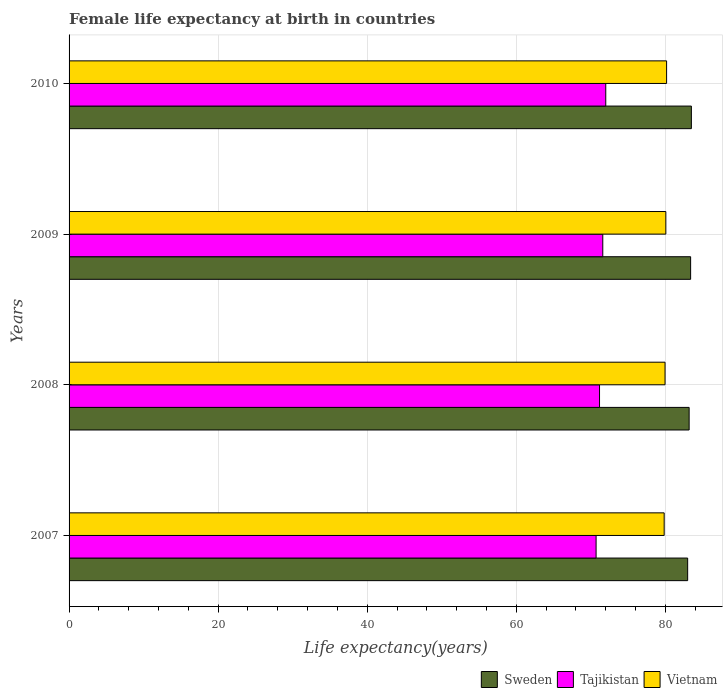How many different coloured bars are there?
Provide a succinct answer. 3. Are the number of bars per tick equal to the number of legend labels?
Ensure brevity in your answer.  Yes. How many bars are there on the 3rd tick from the top?
Offer a terse response. 3. In how many cases, is the number of bars for a given year not equal to the number of legend labels?
Keep it short and to the point. 0. What is the female life expectancy at birth in Vietnam in 2007?
Provide a short and direct response. 79.85. Across all years, what is the maximum female life expectancy at birth in Sweden?
Provide a short and direct response. 83.5. Across all years, what is the minimum female life expectancy at birth in Tajikistan?
Keep it short and to the point. 70.72. In which year was the female life expectancy at birth in Tajikistan maximum?
Make the answer very short. 2010. In which year was the female life expectancy at birth in Vietnam minimum?
Offer a very short reply. 2007. What is the total female life expectancy at birth in Sweden in the graph?
Give a very brief answer. 333.1. What is the difference between the female life expectancy at birth in Vietnam in 2009 and that in 2010?
Your response must be concise. -0.1. What is the difference between the female life expectancy at birth in Vietnam in 2010 and the female life expectancy at birth in Tajikistan in 2009?
Offer a very short reply. 8.56. What is the average female life expectancy at birth in Tajikistan per year?
Provide a succinct answer. 71.38. In the year 2010, what is the difference between the female life expectancy at birth in Sweden and female life expectancy at birth in Tajikistan?
Your answer should be compact. 11.49. In how many years, is the female life expectancy at birth in Tajikistan greater than 56 years?
Keep it short and to the point. 4. What is the ratio of the female life expectancy at birth in Sweden in 2007 to that in 2010?
Give a very brief answer. 0.99. What is the difference between the highest and the second highest female life expectancy at birth in Vietnam?
Keep it short and to the point. 0.1. What is the difference between the highest and the lowest female life expectancy at birth in Sweden?
Your answer should be very brief. 0.5. In how many years, is the female life expectancy at birth in Tajikistan greater than the average female life expectancy at birth in Tajikistan taken over all years?
Ensure brevity in your answer.  2. What does the 3rd bar from the top in 2010 represents?
Offer a terse response. Sweden. Is it the case that in every year, the sum of the female life expectancy at birth in Tajikistan and female life expectancy at birth in Sweden is greater than the female life expectancy at birth in Vietnam?
Give a very brief answer. Yes. Are all the bars in the graph horizontal?
Give a very brief answer. Yes. What is the difference between two consecutive major ticks on the X-axis?
Keep it short and to the point. 20. Are the values on the major ticks of X-axis written in scientific E-notation?
Keep it short and to the point. No. Does the graph contain any zero values?
Provide a succinct answer. No. Where does the legend appear in the graph?
Provide a short and direct response. Bottom right. How are the legend labels stacked?
Make the answer very short. Horizontal. What is the title of the graph?
Offer a terse response. Female life expectancy at birth in countries. Does "Moldova" appear as one of the legend labels in the graph?
Give a very brief answer. No. What is the label or title of the X-axis?
Offer a terse response. Life expectancy(years). What is the Life expectancy(years) in Tajikistan in 2007?
Offer a very short reply. 70.72. What is the Life expectancy(years) in Vietnam in 2007?
Ensure brevity in your answer.  79.85. What is the Life expectancy(years) in Sweden in 2008?
Offer a terse response. 83.2. What is the Life expectancy(years) in Tajikistan in 2008?
Keep it short and to the point. 71.18. What is the Life expectancy(years) of Vietnam in 2008?
Your answer should be very brief. 79.97. What is the Life expectancy(years) of Sweden in 2009?
Provide a succinct answer. 83.4. What is the Life expectancy(years) of Tajikistan in 2009?
Your answer should be very brief. 71.61. What is the Life expectancy(years) in Vietnam in 2009?
Make the answer very short. 80.07. What is the Life expectancy(years) in Sweden in 2010?
Provide a succinct answer. 83.5. What is the Life expectancy(years) in Tajikistan in 2010?
Your response must be concise. 72.01. What is the Life expectancy(years) in Vietnam in 2010?
Offer a very short reply. 80.17. Across all years, what is the maximum Life expectancy(years) in Sweden?
Your response must be concise. 83.5. Across all years, what is the maximum Life expectancy(years) of Tajikistan?
Your answer should be compact. 72.01. Across all years, what is the maximum Life expectancy(years) in Vietnam?
Keep it short and to the point. 80.17. Across all years, what is the minimum Life expectancy(years) of Tajikistan?
Keep it short and to the point. 70.72. Across all years, what is the minimum Life expectancy(years) in Vietnam?
Offer a terse response. 79.85. What is the total Life expectancy(years) of Sweden in the graph?
Offer a terse response. 333.1. What is the total Life expectancy(years) in Tajikistan in the graph?
Your response must be concise. 285.52. What is the total Life expectancy(years) in Vietnam in the graph?
Provide a short and direct response. 320.06. What is the difference between the Life expectancy(years) in Tajikistan in 2007 and that in 2008?
Ensure brevity in your answer.  -0.46. What is the difference between the Life expectancy(years) of Vietnam in 2007 and that in 2008?
Ensure brevity in your answer.  -0.12. What is the difference between the Life expectancy(years) in Sweden in 2007 and that in 2009?
Your response must be concise. -0.4. What is the difference between the Life expectancy(years) in Tajikistan in 2007 and that in 2009?
Make the answer very short. -0.9. What is the difference between the Life expectancy(years) in Vietnam in 2007 and that in 2009?
Give a very brief answer. -0.22. What is the difference between the Life expectancy(years) in Sweden in 2007 and that in 2010?
Offer a terse response. -0.5. What is the difference between the Life expectancy(years) of Tajikistan in 2007 and that in 2010?
Keep it short and to the point. -1.3. What is the difference between the Life expectancy(years) of Vietnam in 2007 and that in 2010?
Your response must be concise. -0.32. What is the difference between the Life expectancy(years) of Sweden in 2008 and that in 2009?
Offer a very short reply. -0.2. What is the difference between the Life expectancy(years) of Tajikistan in 2008 and that in 2009?
Provide a succinct answer. -0.44. What is the difference between the Life expectancy(years) in Vietnam in 2008 and that in 2009?
Keep it short and to the point. -0.11. What is the difference between the Life expectancy(years) in Tajikistan in 2008 and that in 2010?
Your answer should be compact. -0.84. What is the difference between the Life expectancy(years) in Vietnam in 2008 and that in 2010?
Your answer should be very brief. -0.21. What is the difference between the Life expectancy(years) of Tajikistan in 2009 and that in 2010?
Make the answer very short. -0.4. What is the difference between the Life expectancy(years) of Vietnam in 2009 and that in 2010?
Give a very brief answer. -0.1. What is the difference between the Life expectancy(years) of Sweden in 2007 and the Life expectancy(years) of Tajikistan in 2008?
Ensure brevity in your answer.  11.82. What is the difference between the Life expectancy(years) in Sweden in 2007 and the Life expectancy(years) in Vietnam in 2008?
Keep it short and to the point. 3.03. What is the difference between the Life expectancy(years) in Tajikistan in 2007 and the Life expectancy(years) in Vietnam in 2008?
Your answer should be compact. -9.25. What is the difference between the Life expectancy(years) of Sweden in 2007 and the Life expectancy(years) of Tajikistan in 2009?
Offer a very short reply. 11.39. What is the difference between the Life expectancy(years) of Sweden in 2007 and the Life expectancy(years) of Vietnam in 2009?
Your answer should be very brief. 2.93. What is the difference between the Life expectancy(years) of Tajikistan in 2007 and the Life expectancy(years) of Vietnam in 2009?
Keep it short and to the point. -9.36. What is the difference between the Life expectancy(years) of Sweden in 2007 and the Life expectancy(years) of Tajikistan in 2010?
Ensure brevity in your answer.  10.99. What is the difference between the Life expectancy(years) of Sweden in 2007 and the Life expectancy(years) of Vietnam in 2010?
Give a very brief answer. 2.83. What is the difference between the Life expectancy(years) of Tajikistan in 2007 and the Life expectancy(years) of Vietnam in 2010?
Keep it short and to the point. -9.46. What is the difference between the Life expectancy(years) of Sweden in 2008 and the Life expectancy(years) of Tajikistan in 2009?
Provide a short and direct response. 11.59. What is the difference between the Life expectancy(years) in Sweden in 2008 and the Life expectancy(years) in Vietnam in 2009?
Ensure brevity in your answer.  3.13. What is the difference between the Life expectancy(years) in Tajikistan in 2008 and the Life expectancy(years) in Vietnam in 2009?
Provide a succinct answer. -8.9. What is the difference between the Life expectancy(years) of Sweden in 2008 and the Life expectancy(years) of Tajikistan in 2010?
Offer a terse response. 11.19. What is the difference between the Life expectancy(years) of Sweden in 2008 and the Life expectancy(years) of Vietnam in 2010?
Your response must be concise. 3.03. What is the difference between the Life expectancy(years) in Tajikistan in 2008 and the Life expectancy(years) in Vietnam in 2010?
Your response must be concise. -9. What is the difference between the Life expectancy(years) in Sweden in 2009 and the Life expectancy(years) in Tajikistan in 2010?
Give a very brief answer. 11.39. What is the difference between the Life expectancy(years) in Sweden in 2009 and the Life expectancy(years) in Vietnam in 2010?
Ensure brevity in your answer.  3.23. What is the difference between the Life expectancy(years) in Tajikistan in 2009 and the Life expectancy(years) in Vietnam in 2010?
Your answer should be compact. -8.56. What is the average Life expectancy(years) of Sweden per year?
Keep it short and to the point. 83.28. What is the average Life expectancy(years) of Tajikistan per year?
Offer a very short reply. 71.38. What is the average Life expectancy(years) of Vietnam per year?
Your answer should be very brief. 80.02. In the year 2007, what is the difference between the Life expectancy(years) of Sweden and Life expectancy(years) of Tajikistan?
Your answer should be very brief. 12.29. In the year 2007, what is the difference between the Life expectancy(years) in Sweden and Life expectancy(years) in Vietnam?
Give a very brief answer. 3.15. In the year 2007, what is the difference between the Life expectancy(years) of Tajikistan and Life expectancy(years) of Vietnam?
Keep it short and to the point. -9.13. In the year 2008, what is the difference between the Life expectancy(years) of Sweden and Life expectancy(years) of Tajikistan?
Offer a very short reply. 12.02. In the year 2008, what is the difference between the Life expectancy(years) of Sweden and Life expectancy(years) of Vietnam?
Offer a terse response. 3.23. In the year 2008, what is the difference between the Life expectancy(years) of Tajikistan and Life expectancy(years) of Vietnam?
Your answer should be compact. -8.79. In the year 2009, what is the difference between the Life expectancy(years) of Sweden and Life expectancy(years) of Tajikistan?
Ensure brevity in your answer.  11.79. In the year 2009, what is the difference between the Life expectancy(years) of Sweden and Life expectancy(years) of Vietnam?
Provide a short and direct response. 3.33. In the year 2009, what is the difference between the Life expectancy(years) in Tajikistan and Life expectancy(years) in Vietnam?
Ensure brevity in your answer.  -8.46. In the year 2010, what is the difference between the Life expectancy(years) in Sweden and Life expectancy(years) in Tajikistan?
Your answer should be compact. 11.49. In the year 2010, what is the difference between the Life expectancy(years) of Sweden and Life expectancy(years) of Vietnam?
Offer a very short reply. 3.33. In the year 2010, what is the difference between the Life expectancy(years) of Tajikistan and Life expectancy(years) of Vietnam?
Offer a terse response. -8.16. What is the ratio of the Life expectancy(years) of Sweden in 2007 to that in 2008?
Ensure brevity in your answer.  1. What is the ratio of the Life expectancy(years) of Tajikistan in 2007 to that in 2008?
Offer a very short reply. 0.99. What is the ratio of the Life expectancy(years) in Tajikistan in 2007 to that in 2009?
Your answer should be compact. 0.99. What is the ratio of the Life expectancy(years) in Sweden in 2007 to that in 2010?
Provide a succinct answer. 0.99. What is the ratio of the Life expectancy(years) of Sweden in 2008 to that in 2009?
Your response must be concise. 1. What is the ratio of the Life expectancy(years) of Tajikistan in 2008 to that in 2010?
Make the answer very short. 0.99. What is the ratio of the Life expectancy(years) in Tajikistan in 2009 to that in 2010?
Offer a terse response. 0.99. What is the ratio of the Life expectancy(years) of Vietnam in 2009 to that in 2010?
Keep it short and to the point. 1. What is the difference between the highest and the second highest Life expectancy(years) of Sweden?
Provide a short and direct response. 0.1. What is the difference between the highest and the second highest Life expectancy(years) in Tajikistan?
Give a very brief answer. 0.4. What is the difference between the highest and the lowest Life expectancy(years) in Sweden?
Provide a short and direct response. 0.5. What is the difference between the highest and the lowest Life expectancy(years) of Tajikistan?
Your answer should be very brief. 1.3. What is the difference between the highest and the lowest Life expectancy(years) in Vietnam?
Give a very brief answer. 0.32. 